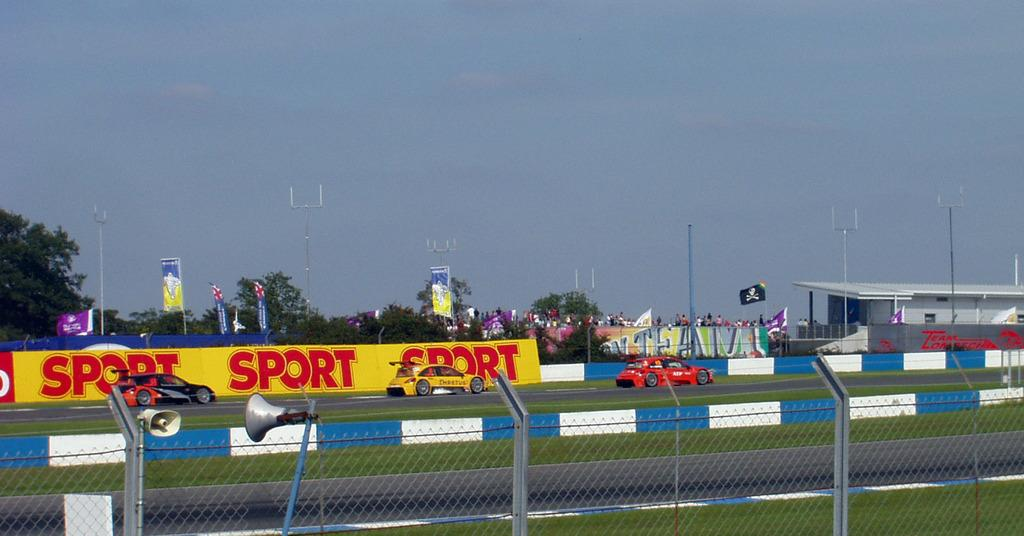<image>
Write a terse but informative summary of the picture. Cars race down a track past a sign that repeats the work sport three times. 